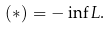<formula> <loc_0><loc_0><loc_500><loc_500>( * ) = - \inf L .</formula> 